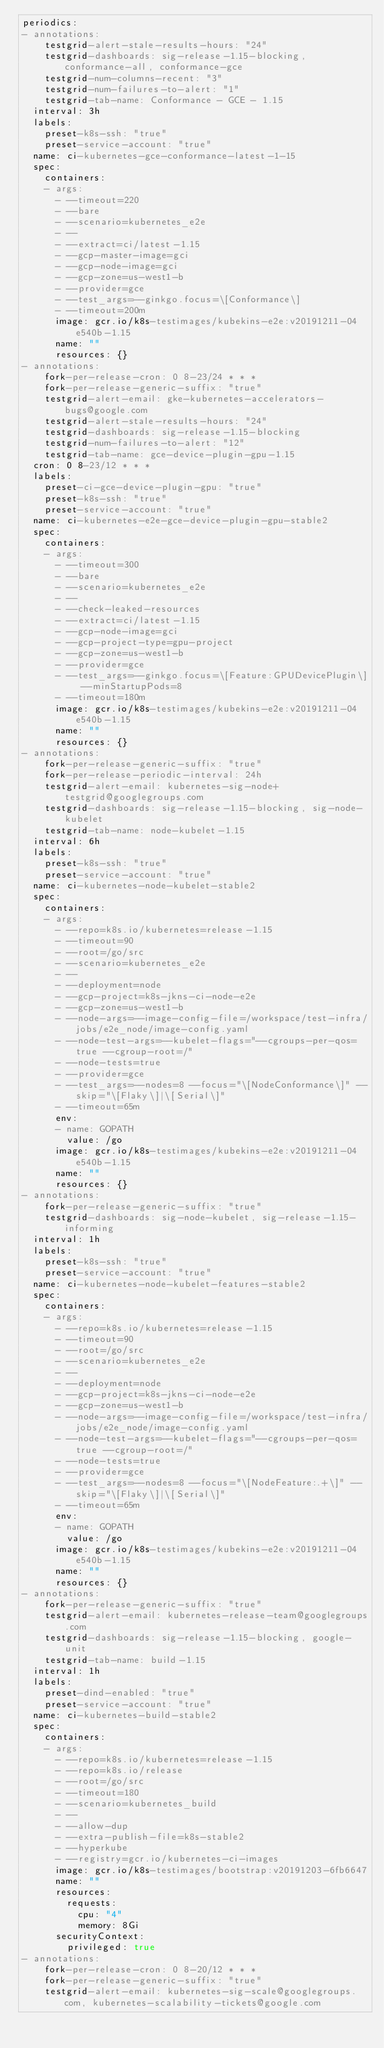<code> <loc_0><loc_0><loc_500><loc_500><_YAML_>periodics:
- annotations:
    testgrid-alert-stale-results-hours: "24"
    testgrid-dashboards: sig-release-1.15-blocking, conformance-all, conformance-gce
    testgrid-num-columns-recent: "3"
    testgrid-num-failures-to-alert: "1"
    testgrid-tab-name: Conformance - GCE - 1.15
  interval: 3h
  labels:
    preset-k8s-ssh: "true"
    preset-service-account: "true"
  name: ci-kubernetes-gce-conformance-latest-1-15
  spec:
    containers:
    - args:
      - --timeout=220
      - --bare
      - --scenario=kubernetes_e2e
      - --
      - --extract=ci/latest-1.15
      - --gcp-master-image=gci
      - --gcp-node-image=gci
      - --gcp-zone=us-west1-b
      - --provider=gce
      - --test_args=--ginkgo.focus=\[Conformance\]
      - --timeout=200m
      image: gcr.io/k8s-testimages/kubekins-e2e:v20191211-04e540b-1.15
      name: ""
      resources: {}
- annotations:
    fork-per-release-cron: 0 8-23/24 * * *
    fork-per-release-generic-suffix: "true"
    testgrid-alert-email: gke-kubernetes-accelerators-bugs@google.com
    testgrid-alert-stale-results-hours: "24"
    testgrid-dashboards: sig-release-1.15-blocking
    testgrid-num-failures-to-alert: "12"
    testgrid-tab-name: gce-device-plugin-gpu-1.15
  cron: 0 8-23/12 * * *
  labels:
    preset-ci-gce-device-plugin-gpu: "true"
    preset-k8s-ssh: "true"
    preset-service-account: "true"
  name: ci-kubernetes-e2e-gce-device-plugin-gpu-stable2
  spec:
    containers:
    - args:
      - --timeout=300
      - --bare
      - --scenario=kubernetes_e2e
      - --
      - --check-leaked-resources
      - --extract=ci/latest-1.15
      - --gcp-node-image=gci
      - --gcp-project-type=gpu-project
      - --gcp-zone=us-west1-b
      - --provider=gce
      - --test_args=--ginkgo.focus=\[Feature:GPUDevicePlugin\] --minStartupPods=8
      - --timeout=180m
      image: gcr.io/k8s-testimages/kubekins-e2e:v20191211-04e540b-1.15
      name: ""
      resources: {}
- annotations:
    fork-per-release-generic-suffix: "true"
    fork-per-release-periodic-interval: 24h
    testgrid-alert-email: kubernetes-sig-node+testgrid@googlegroups.com
    testgrid-dashboards: sig-release-1.15-blocking, sig-node-kubelet
    testgrid-tab-name: node-kubelet-1.15
  interval: 6h
  labels:
    preset-k8s-ssh: "true"
    preset-service-account: "true"
  name: ci-kubernetes-node-kubelet-stable2
  spec:
    containers:
    - args:
      - --repo=k8s.io/kubernetes=release-1.15
      - --timeout=90
      - --root=/go/src
      - --scenario=kubernetes_e2e
      - --
      - --deployment=node
      - --gcp-project=k8s-jkns-ci-node-e2e
      - --gcp-zone=us-west1-b
      - --node-args=--image-config-file=/workspace/test-infra/jobs/e2e_node/image-config.yaml
      - --node-test-args=--kubelet-flags="--cgroups-per-qos=true --cgroup-root=/"
      - --node-tests=true
      - --provider=gce
      - --test_args=--nodes=8 --focus="\[NodeConformance\]" --skip="\[Flaky\]|\[Serial\]"
      - --timeout=65m
      env:
      - name: GOPATH
        value: /go
      image: gcr.io/k8s-testimages/kubekins-e2e:v20191211-04e540b-1.15
      name: ""
      resources: {}
- annotations:
    fork-per-release-generic-suffix: "true"
    testgrid-dashboards: sig-node-kubelet, sig-release-1.15-informing
  interval: 1h
  labels:
    preset-k8s-ssh: "true"
    preset-service-account: "true"
  name: ci-kubernetes-node-kubelet-features-stable2
  spec:
    containers:
    - args:
      - --repo=k8s.io/kubernetes=release-1.15
      - --timeout=90
      - --root=/go/src
      - --scenario=kubernetes_e2e
      - --
      - --deployment=node
      - --gcp-project=k8s-jkns-ci-node-e2e
      - --gcp-zone=us-west1-b
      - --node-args=--image-config-file=/workspace/test-infra/jobs/e2e_node/image-config.yaml
      - --node-test-args=--kubelet-flags="--cgroups-per-qos=true --cgroup-root=/"
      - --node-tests=true
      - --provider=gce
      - --test_args=--nodes=8 --focus="\[NodeFeature:.+\]" --skip="\[Flaky\]|\[Serial\]"
      - --timeout=65m
      env:
      - name: GOPATH
        value: /go
      image: gcr.io/k8s-testimages/kubekins-e2e:v20191211-04e540b-1.15
      name: ""
      resources: {}
- annotations:
    fork-per-release-generic-suffix: "true"
    testgrid-alert-email: kubernetes-release-team@googlegroups.com
    testgrid-dashboards: sig-release-1.15-blocking, google-unit
    testgrid-tab-name: build-1.15
  interval: 1h
  labels:
    preset-dind-enabled: "true"
    preset-service-account: "true"
  name: ci-kubernetes-build-stable2
  spec:
    containers:
    - args:
      - --repo=k8s.io/kubernetes=release-1.15
      - --repo=k8s.io/release
      - --root=/go/src
      - --timeout=180
      - --scenario=kubernetes_build
      - --
      - --allow-dup
      - --extra-publish-file=k8s-stable2
      - --hyperkube
      - --registry=gcr.io/kubernetes-ci-images
      image: gcr.io/k8s-testimages/bootstrap:v20191203-6fb6647
      name: ""
      resources:
        requests:
          cpu: "4"
          memory: 8Gi
      securityContext:
        privileged: true
- annotations:
    fork-per-release-cron: 0 8-20/12 * * *
    fork-per-release-generic-suffix: "true"
    testgrid-alert-email: kubernetes-sig-scale@googlegroups.com, kubernetes-scalability-tickets@google.com</code> 